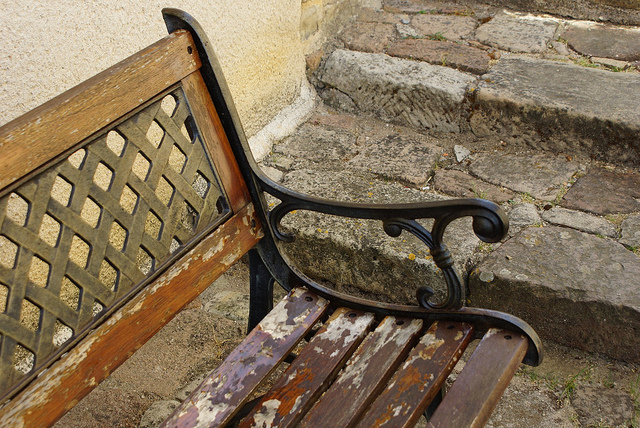Can you describe the setting or location where the bench is situated? The bench is situated in an outdoor locale, likely a public space such as a park or a pedestrian area near buildings. The cobblestone ground and the stone steps evoke a quaint or historical ambience possibly found in a European town or village. Does the bench seem like it's still in use based on its condition? Despite the signs of wear, such as peeling paint and weathered wood, the bench appears structurally sound, suggesting it could still be in use for seating, though its comfort might be compromised until it is refurbished. 